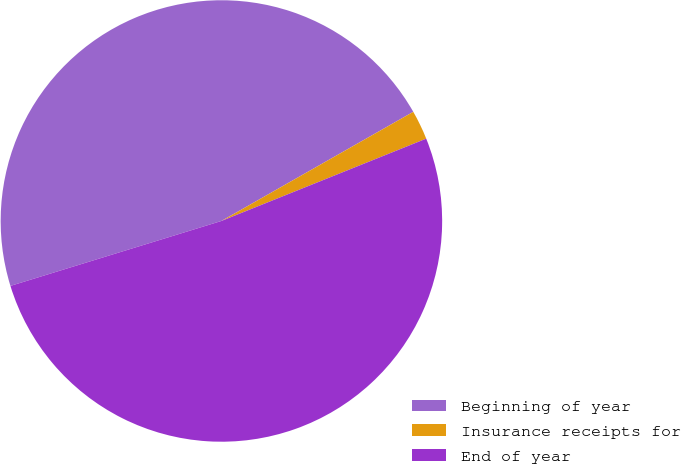Convert chart to OTSL. <chart><loc_0><loc_0><loc_500><loc_500><pie_chart><fcel>Beginning of year<fcel>Insurance receipts for<fcel>End of year<nl><fcel>46.52%<fcel>2.15%<fcel>51.33%<nl></chart> 